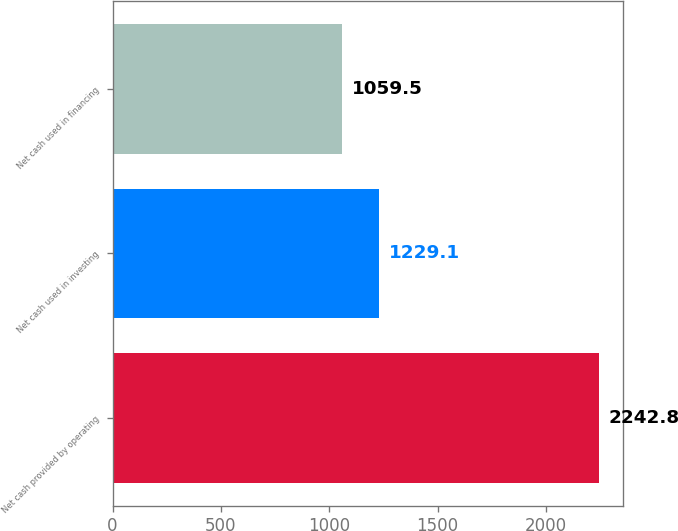<chart> <loc_0><loc_0><loc_500><loc_500><bar_chart><fcel>Net cash provided by operating<fcel>Net cash used in investing<fcel>Net cash used in financing<nl><fcel>2242.8<fcel>1229.1<fcel>1059.5<nl></chart> 